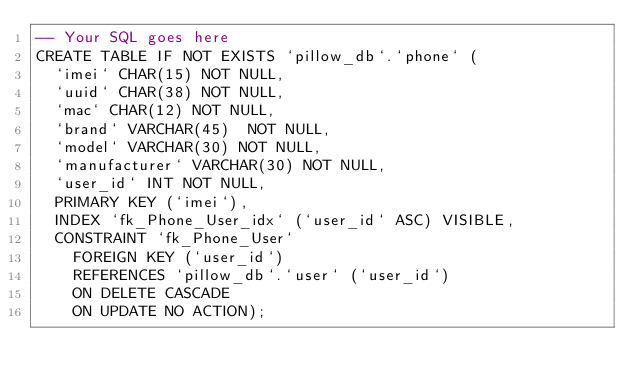<code> <loc_0><loc_0><loc_500><loc_500><_SQL_>-- Your SQL goes here
CREATE TABLE IF NOT EXISTS `pillow_db`.`phone` (
  `imei` CHAR(15) NOT NULL,
  `uuid` CHAR(38) NOT NULL,
  `mac` CHAR(12) NOT NULL,
  `brand` VARCHAR(45)  NOT NULL,
  `model` VARCHAR(30) NOT NULL,
  `manufacturer` VARCHAR(30) NOT NULL,
  `user_id` INT NOT NULL,
  PRIMARY KEY (`imei`),
  INDEX `fk_Phone_User_idx` (`user_id` ASC) VISIBLE,
  CONSTRAINT `fk_Phone_User`
    FOREIGN KEY (`user_id`)
    REFERENCES `pillow_db`.`user` (`user_id`)
    ON DELETE CASCADE
    ON UPDATE NO ACTION);</code> 